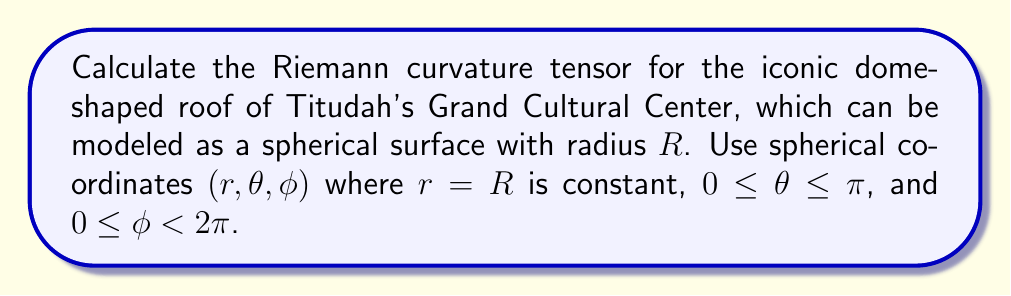What is the answer to this math problem? Let's approach this step-by-step:

1) The metric tensor for a sphere in spherical coordinates is:
   $$ds^2 = R^2 d\theta^2 + R^2 \sin^2\theta d\phi^2$$

2) The non-zero components of the metric tensor are:
   $$g_{\theta\theta} = R^2, \quad g_{\phi\phi} = R^2 \sin^2\theta$$

3) The non-zero Christoffel symbols are:
   $$\Gamma^\theta_{\phi\phi} = -\sin\theta \cos\theta$$
   $$\Gamma^\phi_{\theta\phi} = \Gamma^\phi_{\phi\theta} = \cot\theta$$

4) The Riemann curvature tensor is given by:
   $$R^{\rho}_{\sigma\mu\nu} = \partial_\mu \Gamma^{\rho}_{\sigma\nu} - \partial_\nu \Gamma^{\rho}_{\sigma\mu} + \Gamma^{\rho}_{\lambda\mu}\Gamma^{\lambda}_{\sigma\nu} - \Gamma^{\rho}_{\lambda\nu}\Gamma^{\lambda}_{\sigma\mu}$$

5) Calculating the non-zero components:
   $$R^{\theta}_{\phi\theta\phi} = -\sin^2\theta$$
   $$R^{\phi}_{\theta\phi\theta} = 1$$

6) Lowering the first index:
   $$R_{\theta\phi\theta\phi} = g_{\theta\theta}R^{\theta}_{\phi\theta\phi} = -R^2\sin^2\theta$$
   $$R_{\phi\theta\phi\theta} = g_{\phi\phi}R^{\phi}_{\theta\phi\theta} = R^2\sin^2\theta$$

7) All other components are either zero or can be obtained by symmetry/antisymmetry properties of the Riemann tensor.
Answer: $R_{\theta\phi\theta\phi} = -R^2\sin^2\theta$, $R_{\phi\theta\phi\theta} = R^2\sin^2\theta$ 